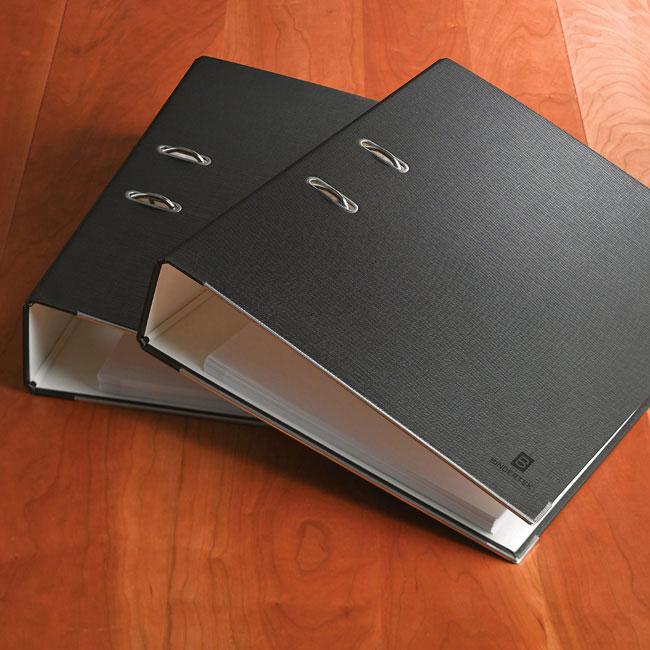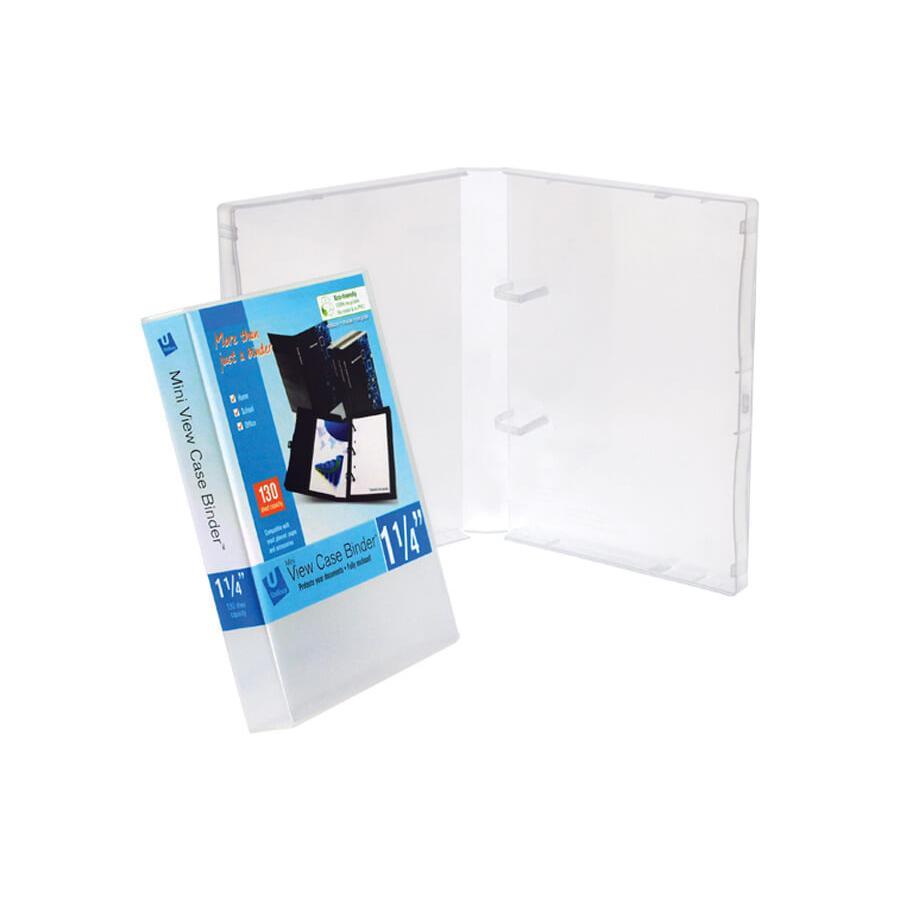The first image is the image on the left, the second image is the image on the right. Evaluate the accuracy of this statement regarding the images: "An image includes a black upright binder with a black circle below a white rectangle on its end.". Is it true? Answer yes or no. No. The first image is the image on the left, the second image is the image on the right. Examine the images to the left and right. Is the description "There are two black binders on a wooden surface." accurate? Answer yes or no. Yes. 